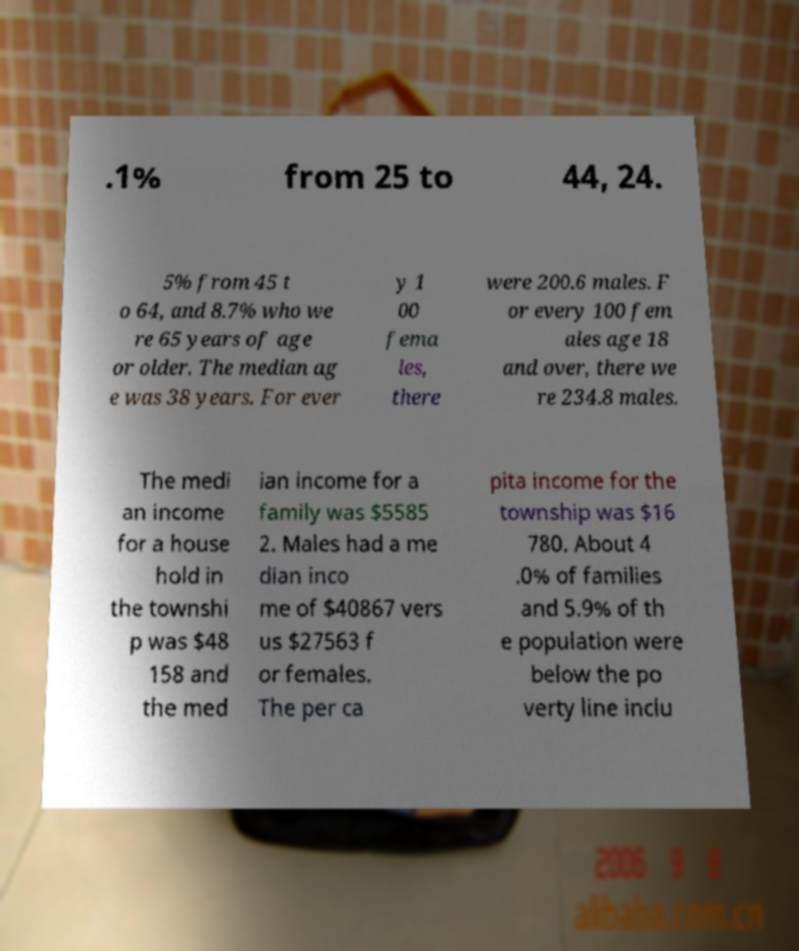For documentation purposes, I need the text within this image transcribed. Could you provide that? .1% from 25 to 44, 24. 5% from 45 t o 64, and 8.7% who we re 65 years of age or older. The median ag e was 38 years. For ever y 1 00 fema les, there were 200.6 males. F or every 100 fem ales age 18 and over, there we re 234.8 males. The medi an income for a house hold in the townshi p was $48 158 and the med ian income for a family was $5585 2. Males had a me dian inco me of $40867 vers us $27563 f or females. The per ca pita income for the township was $16 780. About 4 .0% of families and 5.9% of th e population were below the po verty line inclu 